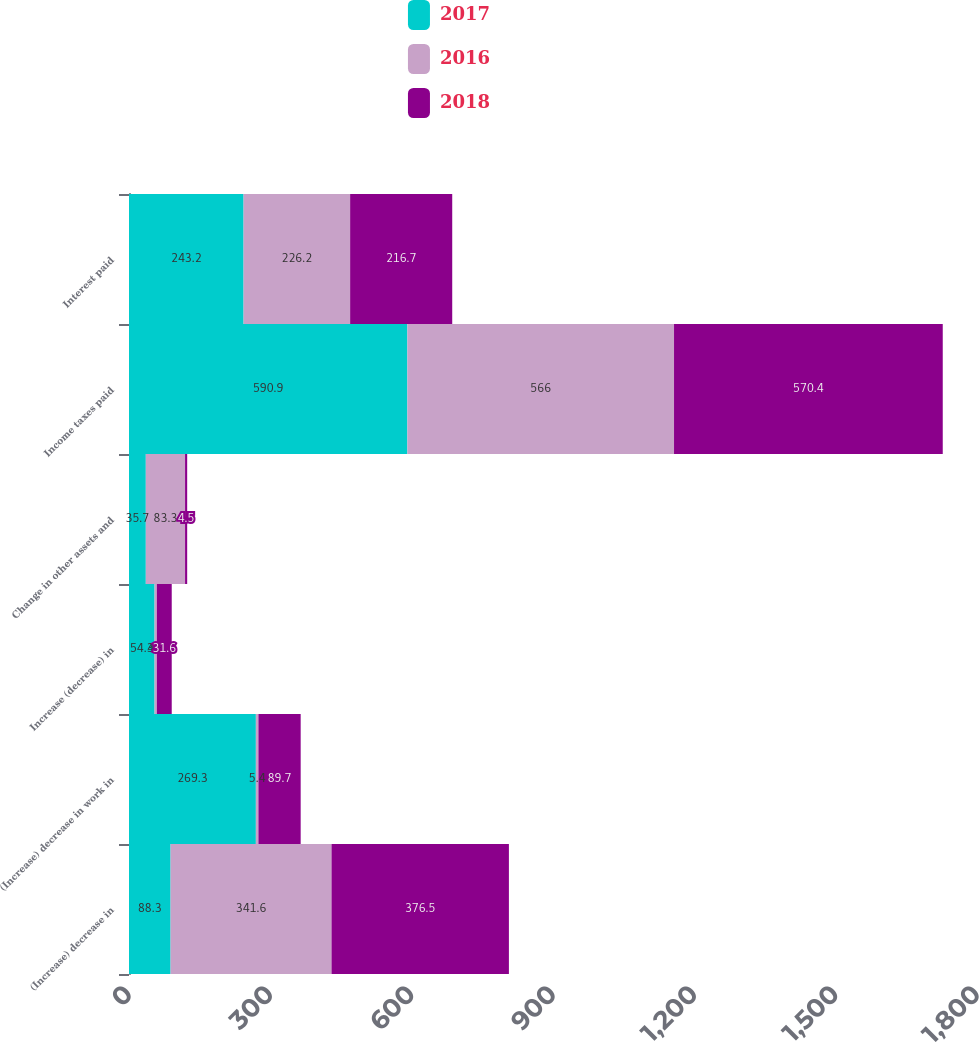Convert chart to OTSL. <chart><loc_0><loc_0><loc_500><loc_500><stacked_bar_chart><ecel><fcel>(Increase) decrease in<fcel>(Increase) decrease in work in<fcel>Increase (decrease) in<fcel>Change in other assets and<fcel>Income taxes paid<fcel>Interest paid<nl><fcel>2017<fcel>88.3<fcel>269.3<fcel>54.3<fcel>35.7<fcel>590.9<fcel>243.2<nl><fcel>2016<fcel>341.6<fcel>5.4<fcel>4.8<fcel>83.3<fcel>566<fcel>226.2<nl><fcel>2018<fcel>376.5<fcel>89.7<fcel>31.6<fcel>4.5<fcel>570.4<fcel>216.7<nl></chart> 